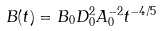<formula> <loc_0><loc_0><loc_500><loc_500>B ( t ) = B _ { 0 } D _ { 0 } ^ { 2 } A _ { 0 } ^ { - 2 } t ^ { - 4 / 5 }</formula> 